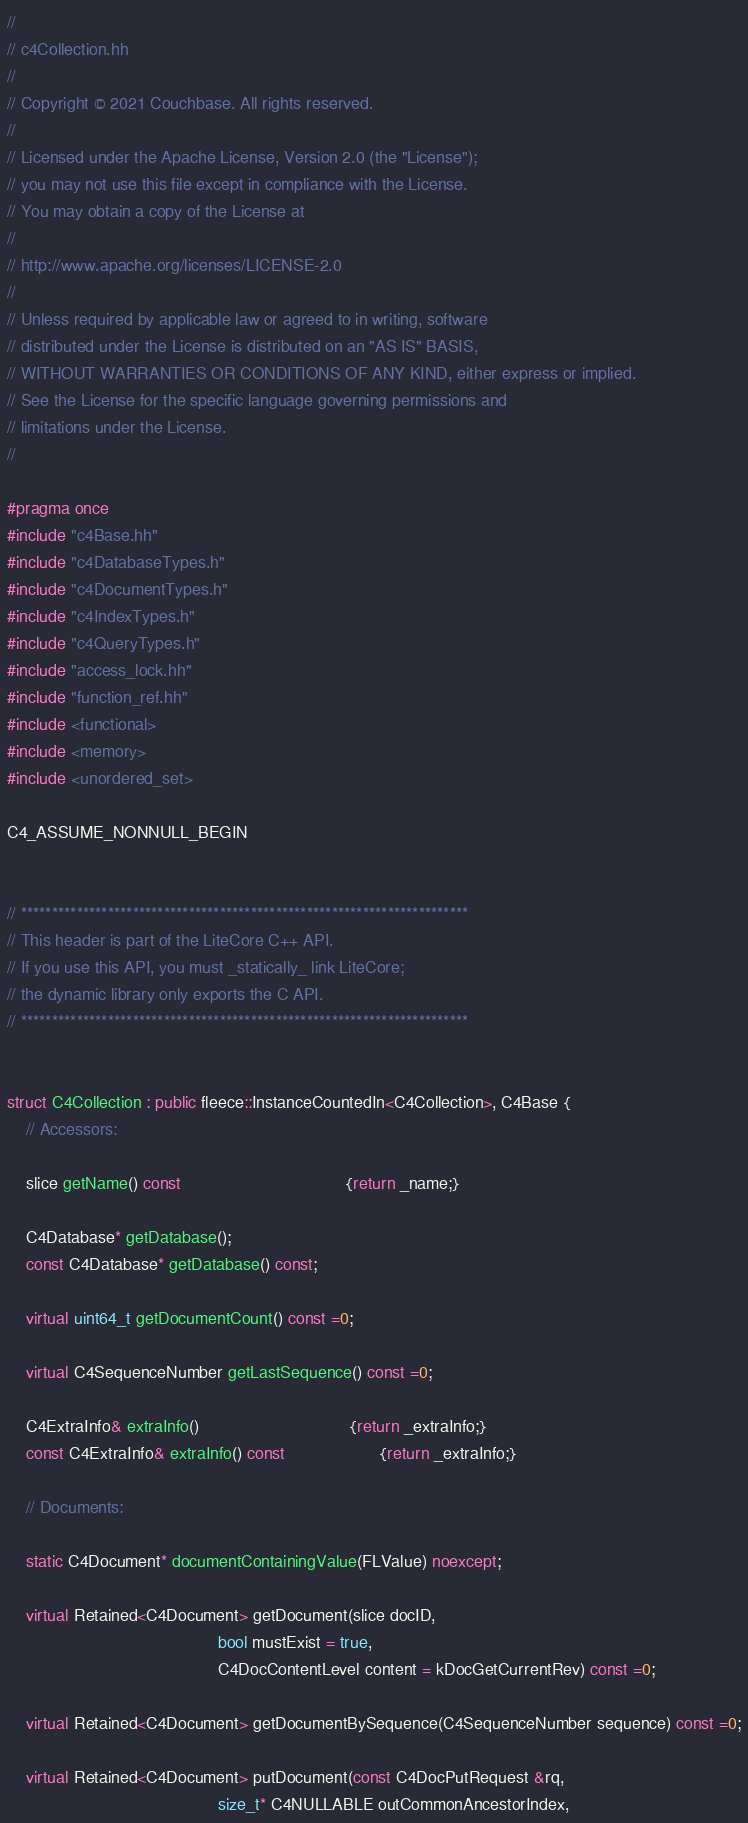Convert code to text. <code><loc_0><loc_0><loc_500><loc_500><_C++_>//
// c4Collection.hh
//
// Copyright © 2021 Couchbase. All rights reserved.
//
// Licensed under the Apache License, Version 2.0 (the "License");
// you may not use this file except in compliance with the License.
// You may obtain a copy of the License at
//
// http://www.apache.org/licenses/LICENSE-2.0
//
// Unless required by applicable law or agreed to in writing, software
// distributed under the License is distributed on an "AS IS" BASIS,
// WITHOUT WARRANTIES OR CONDITIONS OF ANY KIND, either express or implied.
// See the License for the specific language governing permissions and
// limitations under the License.
//

#pragma once
#include "c4Base.hh"
#include "c4DatabaseTypes.h"
#include "c4DocumentTypes.h"
#include "c4IndexTypes.h"
#include "c4QueryTypes.h"
#include "access_lock.hh"
#include "function_ref.hh"
#include <functional>
#include <memory>
#include <unordered_set>

C4_ASSUME_NONNULL_BEGIN


// ************************************************************************
// This header is part of the LiteCore C++ API.
// If you use this API, you must _statically_ link LiteCore;
// the dynamic library only exports the C API.
// ************************************************************************


struct C4Collection : public fleece::InstanceCountedIn<C4Collection>, C4Base {
    // Accessors:
    
    slice getName() const                                   {return _name;}

    C4Database* getDatabase();
    const C4Database* getDatabase() const;

    virtual uint64_t getDocumentCount() const =0;

    virtual C4SequenceNumber getLastSequence() const =0;

    C4ExtraInfo& extraInfo()                                {return _extraInfo;}
    const C4ExtraInfo& extraInfo() const                    {return _extraInfo;}

    // Documents:

    static C4Document* documentContainingValue(FLValue) noexcept;

    virtual Retained<C4Document> getDocument(slice docID,
                                             bool mustExist = true,
                                             C4DocContentLevel content = kDocGetCurrentRev) const =0;

    virtual Retained<C4Document> getDocumentBySequence(C4SequenceNumber sequence) const =0;

    virtual Retained<C4Document> putDocument(const C4DocPutRequest &rq,
                                             size_t* C4NULLABLE outCommonAncestorIndex,</code> 